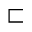<formula> <loc_0><loc_0><loc_500><loc_500>\sqsubset</formula> 